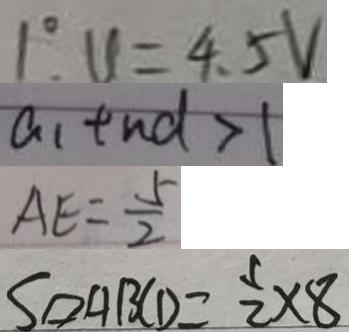Convert formula to latex. <formula><loc_0><loc_0><loc_500><loc_500>1 ^ { \circ } . u = 4 . 5 V 
 a _ { 1 } + n d > 1 
 A E = \frac { 5 } { 2 } 
 S \vert \vert o g r a m A B C D = \frac { 1 } { 2 } \times 8</formula> 